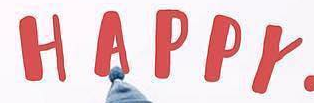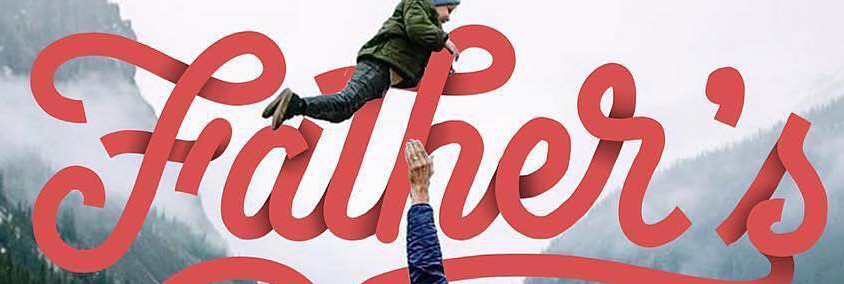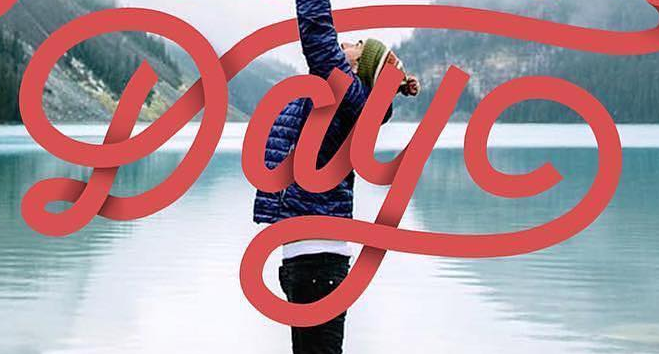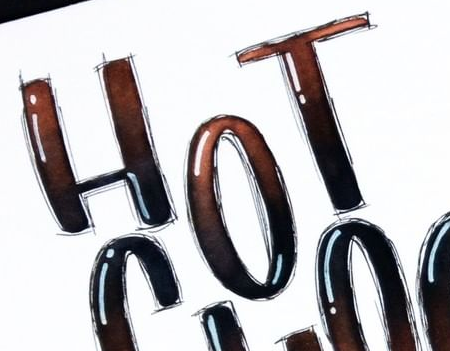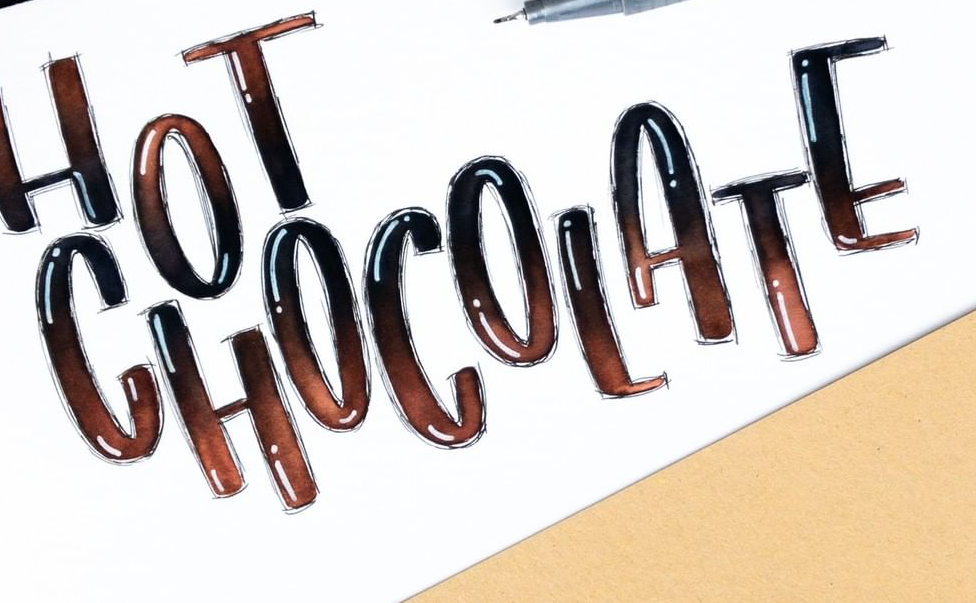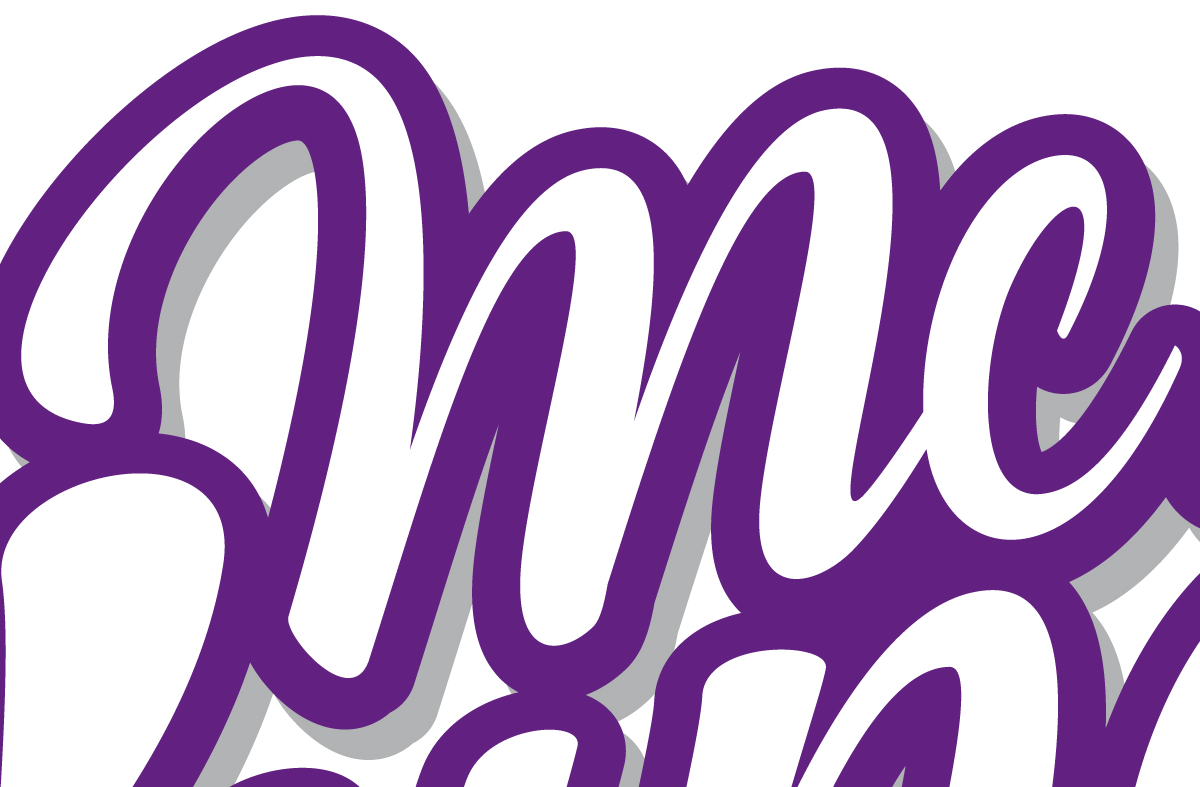What words can you see in these images in sequence, separated by a semicolon? HAPPY; Father's; Day; HOT; CHOCOLATE; mc 